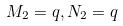<formula> <loc_0><loc_0><loc_500><loc_500>M _ { 2 } = q , N _ { 2 } = q</formula> 